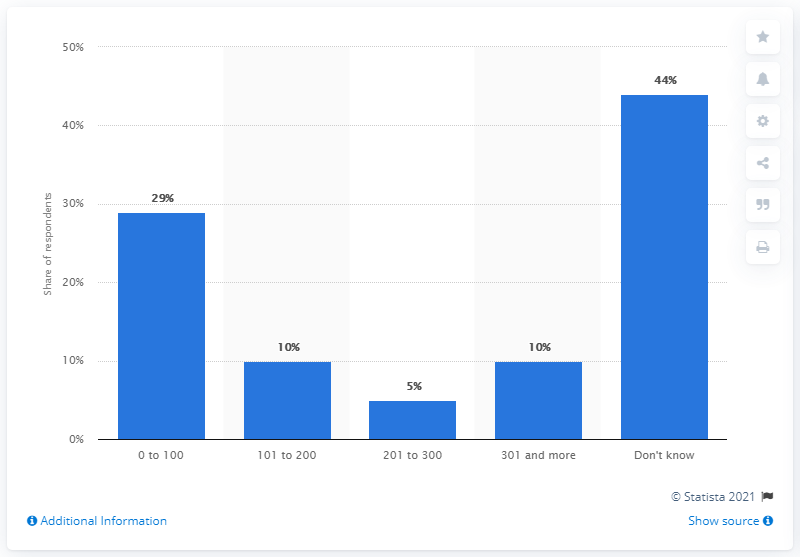Mention a couple of crucial points in this snapshot. In March 2015, approximately 10% of the respondents had 101 to 200 followers on Twitter. 